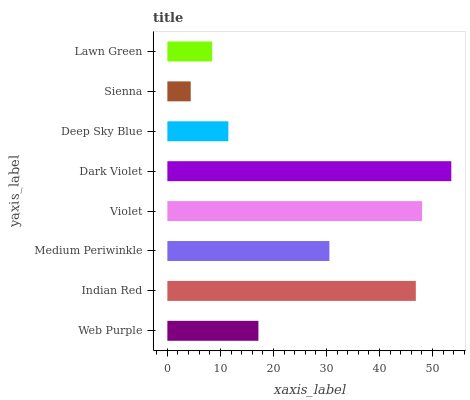Is Sienna the minimum?
Answer yes or no. Yes. Is Dark Violet the maximum?
Answer yes or no. Yes. Is Indian Red the minimum?
Answer yes or no. No. Is Indian Red the maximum?
Answer yes or no. No. Is Indian Red greater than Web Purple?
Answer yes or no. Yes. Is Web Purple less than Indian Red?
Answer yes or no. Yes. Is Web Purple greater than Indian Red?
Answer yes or no. No. Is Indian Red less than Web Purple?
Answer yes or no. No. Is Medium Periwinkle the high median?
Answer yes or no. Yes. Is Web Purple the low median?
Answer yes or no. Yes. Is Dark Violet the high median?
Answer yes or no. No. Is Dark Violet the low median?
Answer yes or no. No. 